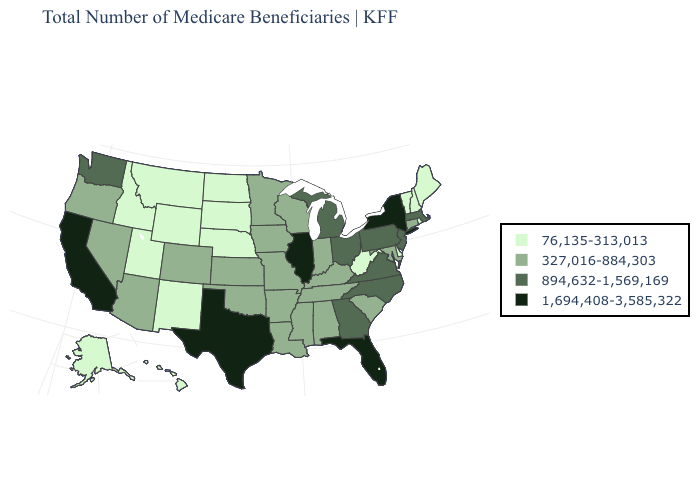What is the value of Arizona?
Concise answer only. 327,016-884,303. Which states hav the highest value in the West?
Short answer required. California. Does Texas have the highest value in the South?
Quick response, please. Yes. What is the highest value in the Northeast ?
Answer briefly. 1,694,408-3,585,322. What is the value of Iowa?
Quick response, please. 327,016-884,303. Does the map have missing data?
Give a very brief answer. No. Name the states that have a value in the range 894,632-1,569,169?
Keep it brief. Georgia, Massachusetts, Michigan, New Jersey, North Carolina, Ohio, Pennsylvania, Virginia, Washington. How many symbols are there in the legend?
Concise answer only. 4. Does Tennessee have a lower value than Ohio?
Write a very short answer. Yes. What is the value of New York?
Give a very brief answer. 1,694,408-3,585,322. What is the value of Wyoming?
Concise answer only. 76,135-313,013. Which states have the lowest value in the Northeast?
Be succinct. Maine, New Hampshire, Rhode Island, Vermont. Name the states that have a value in the range 894,632-1,569,169?
Keep it brief. Georgia, Massachusetts, Michigan, New Jersey, North Carolina, Ohio, Pennsylvania, Virginia, Washington. Name the states that have a value in the range 894,632-1,569,169?
Quick response, please. Georgia, Massachusetts, Michigan, New Jersey, North Carolina, Ohio, Pennsylvania, Virginia, Washington. What is the value of New Hampshire?
Answer briefly. 76,135-313,013. 